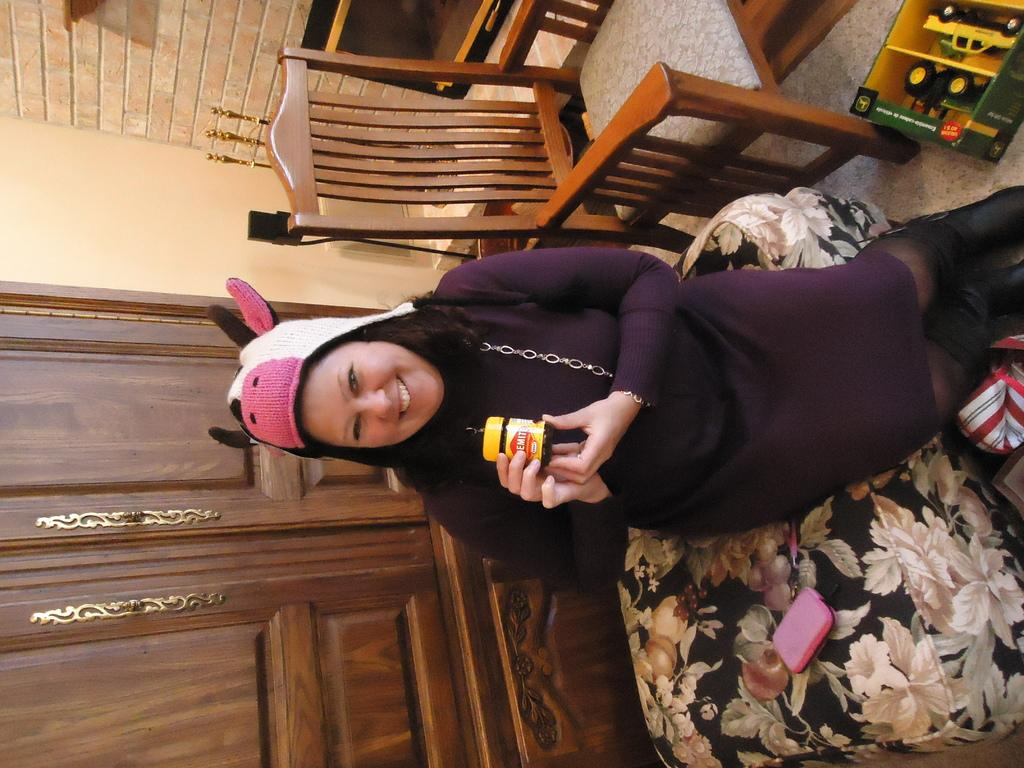What is the main subject of the image? There is a person in the image. What is the person wearing? The person is wearing a violet dress and a white cap. What is the person holding in her hand? The person is holding a bottle in her hand. Where is the person sitting? The person is sitting on a bed. What other furniture can be seen in the image? There is a chair at the top of the image. What type of blood is visible on the person's dress in the image? There is no blood visible on the person's dress in the image. Is there a church in the background of the image? There is no church present in the image. 